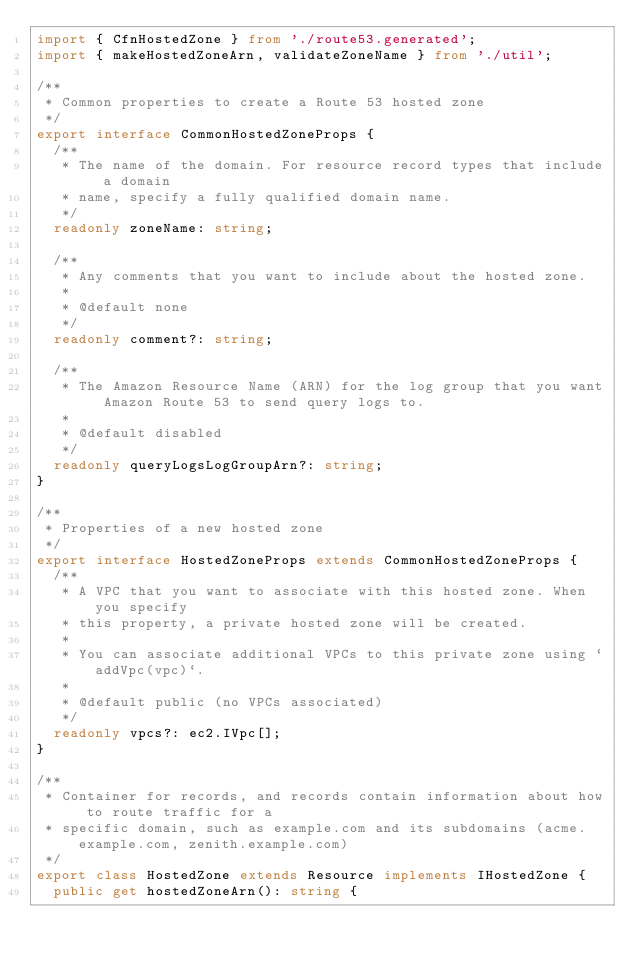<code> <loc_0><loc_0><loc_500><loc_500><_TypeScript_>import { CfnHostedZone } from './route53.generated';
import { makeHostedZoneArn, validateZoneName } from './util';

/**
 * Common properties to create a Route 53 hosted zone
 */
export interface CommonHostedZoneProps {
  /**
   * The name of the domain. For resource record types that include a domain
   * name, specify a fully qualified domain name.
   */
  readonly zoneName: string;

  /**
   * Any comments that you want to include about the hosted zone.
   *
   * @default none
   */
  readonly comment?: string;

  /**
   * The Amazon Resource Name (ARN) for the log group that you want Amazon Route 53 to send query logs to.
   *
   * @default disabled
   */
  readonly queryLogsLogGroupArn?: string;
}

/**
 * Properties of a new hosted zone
 */
export interface HostedZoneProps extends CommonHostedZoneProps {
  /**
   * A VPC that you want to associate with this hosted zone. When you specify
   * this property, a private hosted zone will be created.
   *
   * You can associate additional VPCs to this private zone using `addVpc(vpc)`.
   *
   * @default public (no VPCs associated)
   */
  readonly vpcs?: ec2.IVpc[];
}

/**
 * Container for records, and records contain information about how to route traffic for a
 * specific domain, such as example.com and its subdomains (acme.example.com, zenith.example.com)
 */
export class HostedZone extends Resource implements IHostedZone {
  public get hostedZoneArn(): string {</code> 